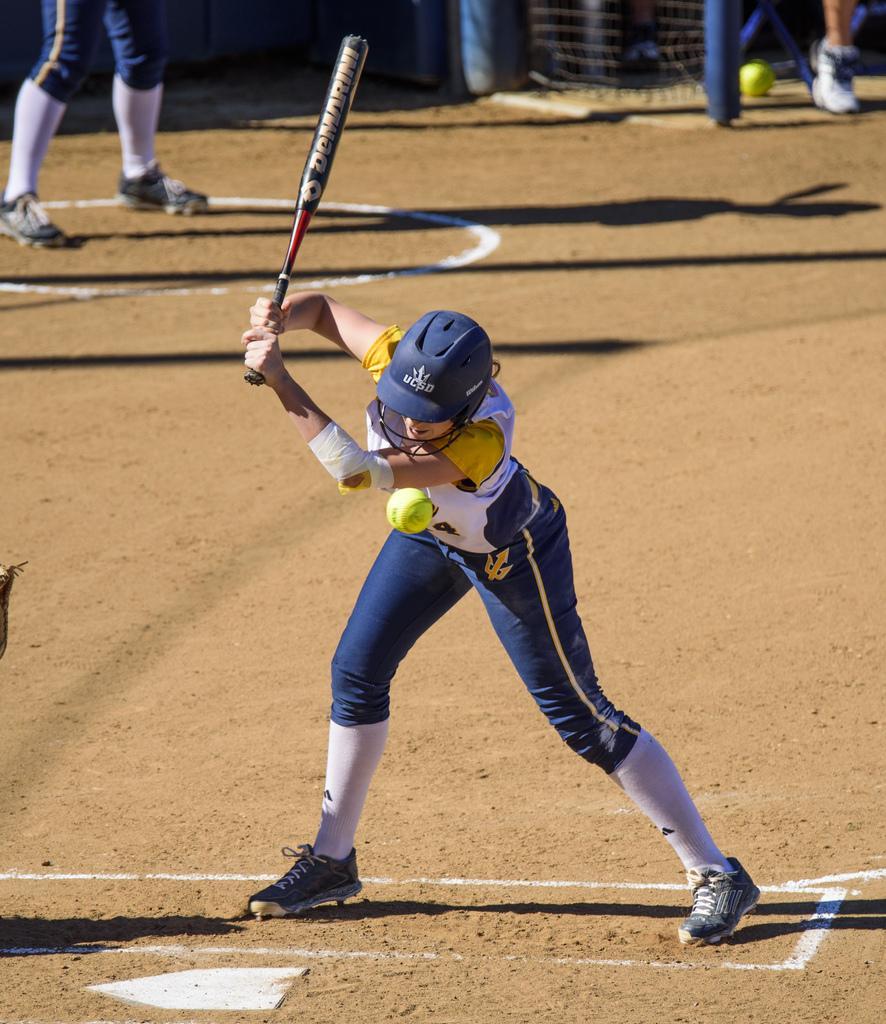Please provide a concise description of this image. In this picture I can see there is a person standing here holding a soccer bat and wearing a helmet and in the backdrop there are some people standing in the playground. 